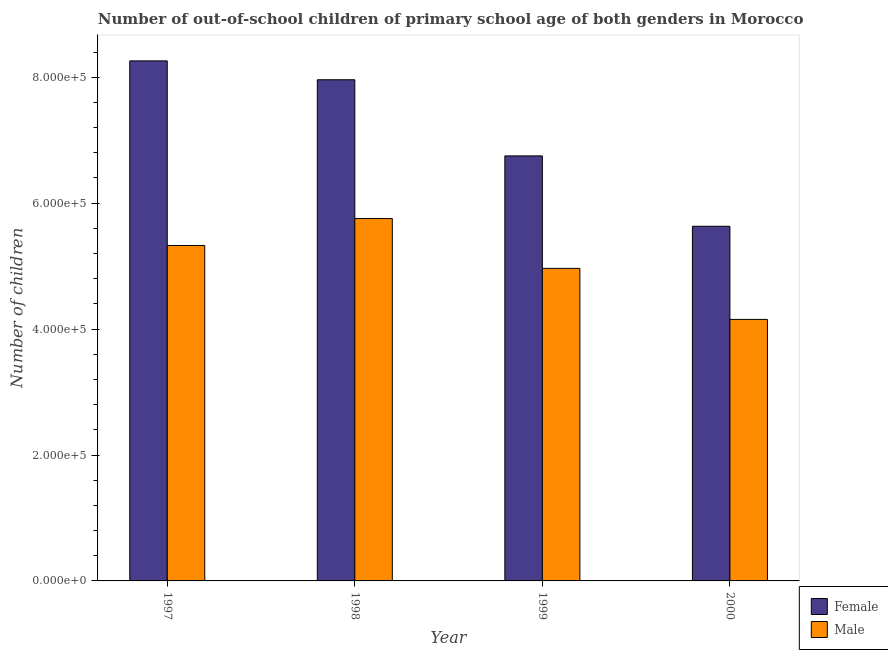Are the number of bars on each tick of the X-axis equal?
Give a very brief answer. Yes. What is the label of the 3rd group of bars from the left?
Provide a succinct answer. 1999. In how many cases, is the number of bars for a given year not equal to the number of legend labels?
Give a very brief answer. 0. What is the number of female out-of-school students in 1999?
Provide a succinct answer. 6.75e+05. Across all years, what is the maximum number of male out-of-school students?
Make the answer very short. 5.76e+05. Across all years, what is the minimum number of male out-of-school students?
Provide a short and direct response. 4.15e+05. In which year was the number of male out-of-school students maximum?
Your response must be concise. 1998. In which year was the number of male out-of-school students minimum?
Keep it short and to the point. 2000. What is the total number of male out-of-school students in the graph?
Provide a succinct answer. 2.02e+06. What is the difference between the number of male out-of-school students in 1997 and that in 1998?
Your response must be concise. -4.28e+04. What is the difference between the number of female out-of-school students in 2000 and the number of male out-of-school students in 1998?
Ensure brevity in your answer.  -2.33e+05. What is the average number of male out-of-school students per year?
Your answer should be compact. 5.05e+05. In how many years, is the number of male out-of-school students greater than 800000?
Give a very brief answer. 0. What is the ratio of the number of female out-of-school students in 1997 to that in 2000?
Provide a short and direct response. 1.47. Is the number of female out-of-school students in 1997 less than that in 1999?
Offer a very short reply. No. Is the difference between the number of female out-of-school students in 1999 and 2000 greater than the difference between the number of male out-of-school students in 1999 and 2000?
Make the answer very short. No. What is the difference between the highest and the second highest number of male out-of-school students?
Provide a succinct answer. 4.28e+04. What is the difference between the highest and the lowest number of male out-of-school students?
Provide a short and direct response. 1.60e+05. Is the sum of the number of female out-of-school students in 1998 and 1999 greater than the maximum number of male out-of-school students across all years?
Your answer should be very brief. Yes. What does the 2nd bar from the right in 1998 represents?
Provide a short and direct response. Female. Are all the bars in the graph horizontal?
Keep it short and to the point. No. How many years are there in the graph?
Provide a short and direct response. 4. What is the difference between two consecutive major ticks on the Y-axis?
Offer a very short reply. 2.00e+05. Are the values on the major ticks of Y-axis written in scientific E-notation?
Keep it short and to the point. Yes. Does the graph contain grids?
Make the answer very short. No. How many legend labels are there?
Ensure brevity in your answer.  2. What is the title of the graph?
Your answer should be very brief. Number of out-of-school children of primary school age of both genders in Morocco. What is the label or title of the X-axis?
Offer a very short reply. Year. What is the label or title of the Y-axis?
Make the answer very short. Number of children. What is the Number of children in Female in 1997?
Ensure brevity in your answer.  8.26e+05. What is the Number of children of Male in 1997?
Give a very brief answer. 5.33e+05. What is the Number of children of Female in 1998?
Provide a short and direct response. 7.96e+05. What is the Number of children in Male in 1998?
Keep it short and to the point. 5.76e+05. What is the Number of children in Female in 1999?
Your response must be concise. 6.75e+05. What is the Number of children of Male in 1999?
Offer a terse response. 4.96e+05. What is the Number of children of Female in 2000?
Ensure brevity in your answer.  5.63e+05. What is the Number of children of Male in 2000?
Provide a short and direct response. 4.15e+05. Across all years, what is the maximum Number of children in Female?
Your response must be concise. 8.26e+05. Across all years, what is the maximum Number of children in Male?
Provide a short and direct response. 5.76e+05. Across all years, what is the minimum Number of children in Female?
Your response must be concise. 5.63e+05. Across all years, what is the minimum Number of children in Male?
Ensure brevity in your answer.  4.15e+05. What is the total Number of children in Female in the graph?
Keep it short and to the point. 2.86e+06. What is the total Number of children in Male in the graph?
Your response must be concise. 2.02e+06. What is the difference between the Number of children of Female in 1997 and that in 1998?
Make the answer very short. 3.00e+04. What is the difference between the Number of children of Male in 1997 and that in 1998?
Give a very brief answer. -4.28e+04. What is the difference between the Number of children of Female in 1997 and that in 1999?
Offer a terse response. 1.51e+05. What is the difference between the Number of children of Male in 1997 and that in 1999?
Provide a short and direct response. 3.64e+04. What is the difference between the Number of children in Female in 1997 and that in 2000?
Offer a terse response. 2.63e+05. What is the difference between the Number of children in Male in 1997 and that in 2000?
Provide a short and direct response. 1.17e+05. What is the difference between the Number of children of Female in 1998 and that in 1999?
Offer a terse response. 1.21e+05. What is the difference between the Number of children in Male in 1998 and that in 1999?
Keep it short and to the point. 7.91e+04. What is the difference between the Number of children in Female in 1998 and that in 2000?
Provide a succinct answer. 2.33e+05. What is the difference between the Number of children of Male in 1998 and that in 2000?
Offer a very short reply. 1.60e+05. What is the difference between the Number of children in Female in 1999 and that in 2000?
Your answer should be very brief. 1.12e+05. What is the difference between the Number of children of Male in 1999 and that in 2000?
Ensure brevity in your answer.  8.11e+04. What is the difference between the Number of children of Female in 1997 and the Number of children of Male in 1998?
Make the answer very short. 2.50e+05. What is the difference between the Number of children in Female in 1997 and the Number of children in Male in 1999?
Ensure brevity in your answer.  3.30e+05. What is the difference between the Number of children of Female in 1997 and the Number of children of Male in 2000?
Provide a succinct answer. 4.11e+05. What is the difference between the Number of children of Female in 1998 and the Number of children of Male in 1999?
Give a very brief answer. 3.00e+05. What is the difference between the Number of children in Female in 1998 and the Number of children in Male in 2000?
Offer a very short reply. 3.81e+05. What is the difference between the Number of children of Female in 1999 and the Number of children of Male in 2000?
Offer a very short reply. 2.60e+05. What is the average Number of children in Female per year?
Ensure brevity in your answer.  7.15e+05. What is the average Number of children in Male per year?
Keep it short and to the point. 5.05e+05. In the year 1997, what is the difference between the Number of children of Female and Number of children of Male?
Offer a terse response. 2.93e+05. In the year 1998, what is the difference between the Number of children in Female and Number of children in Male?
Your response must be concise. 2.20e+05. In the year 1999, what is the difference between the Number of children in Female and Number of children in Male?
Provide a short and direct response. 1.79e+05. In the year 2000, what is the difference between the Number of children in Female and Number of children in Male?
Provide a short and direct response. 1.48e+05. What is the ratio of the Number of children in Female in 1997 to that in 1998?
Your response must be concise. 1.04. What is the ratio of the Number of children in Male in 1997 to that in 1998?
Make the answer very short. 0.93. What is the ratio of the Number of children in Female in 1997 to that in 1999?
Offer a terse response. 1.22. What is the ratio of the Number of children in Male in 1997 to that in 1999?
Your response must be concise. 1.07. What is the ratio of the Number of children of Female in 1997 to that in 2000?
Provide a succinct answer. 1.47. What is the ratio of the Number of children in Male in 1997 to that in 2000?
Your answer should be very brief. 1.28. What is the ratio of the Number of children in Female in 1998 to that in 1999?
Provide a succinct answer. 1.18. What is the ratio of the Number of children of Male in 1998 to that in 1999?
Your response must be concise. 1.16. What is the ratio of the Number of children of Female in 1998 to that in 2000?
Ensure brevity in your answer.  1.41. What is the ratio of the Number of children in Male in 1998 to that in 2000?
Give a very brief answer. 1.39. What is the ratio of the Number of children in Female in 1999 to that in 2000?
Offer a very short reply. 1.2. What is the ratio of the Number of children of Male in 1999 to that in 2000?
Provide a short and direct response. 1.2. What is the difference between the highest and the second highest Number of children of Female?
Provide a short and direct response. 3.00e+04. What is the difference between the highest and the second highest Number of children of Male?
Your answer should be very brief. 4.28e+04. What is the difference between the highest and the lowest Number of children in Female?
Offer a very short reply. 2.63e+05. What is the difference between the highest and the lowest Number of children of Male?
Make the answer very short. 1.60e+05. 